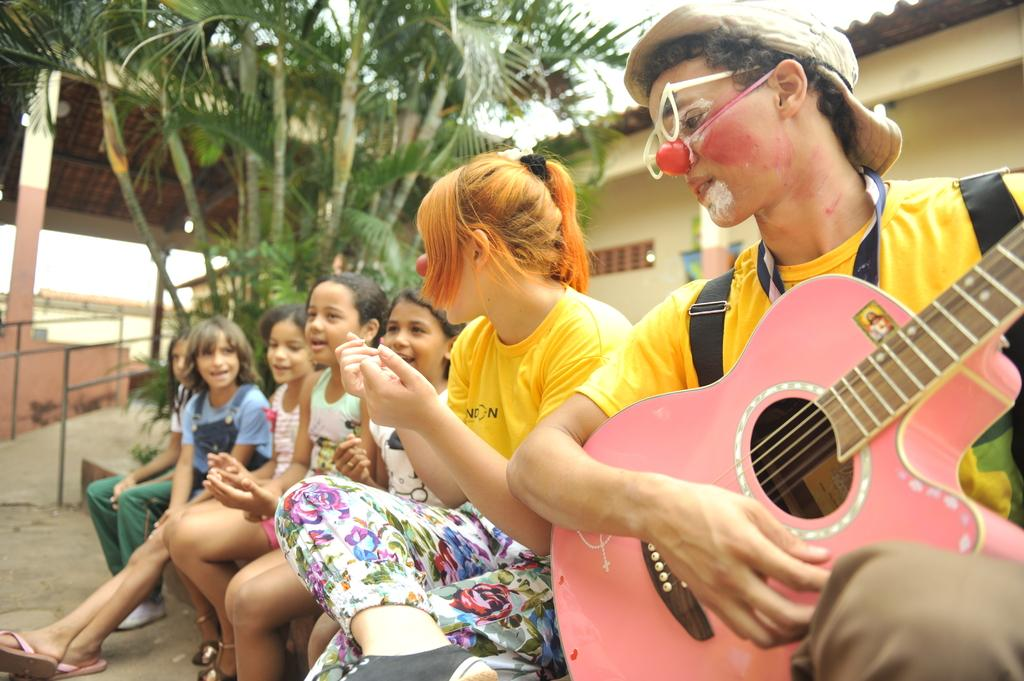What are the people in the image doing? The people in the image are sitting. What is the man holding in the image? The man is holding a guitar in the image. What can be seen in the background of the image? There is a house and trees in the background of the image. What type of cloth is draped over the guitar in the image? There is no cloth draped over the guitar in the image; the man is simply holding it. Can you see any icicles hanging from the trees in the background of the image? There are no icicles visible in the image, as it does not depict a winter scene or freezing temperatures. 